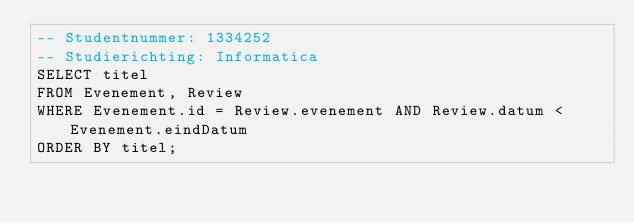Convert code to text. <code><loc_0><loc_0><loc_500><loc_500><_SQL_>-- Studentnummer: 1334252
-- Studierichting: Informatica
SELECT titel
FROM Evenement, Review
WHERE Evenement.id = Review.evenement AND Review.datum < Evenement.eindDatum
ORDER BY titel;</code> 